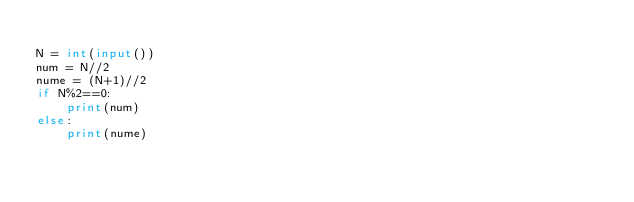Convert code to text. <code><loc_0><loc_0><loc_500><loc_500><_Python_>
N = int(input())
num = N//2
nume = (N+1)//2
if N%2==0:
    print(num)
else:
    print(nume)

</code> 